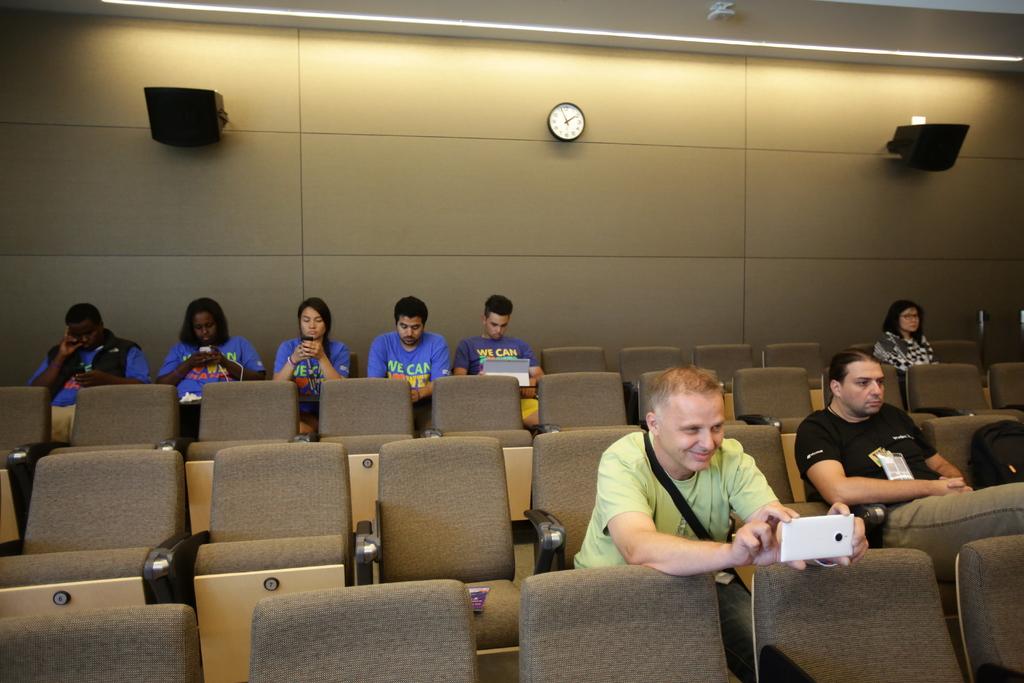What time is it?
Make the answer very short. 11:10. 